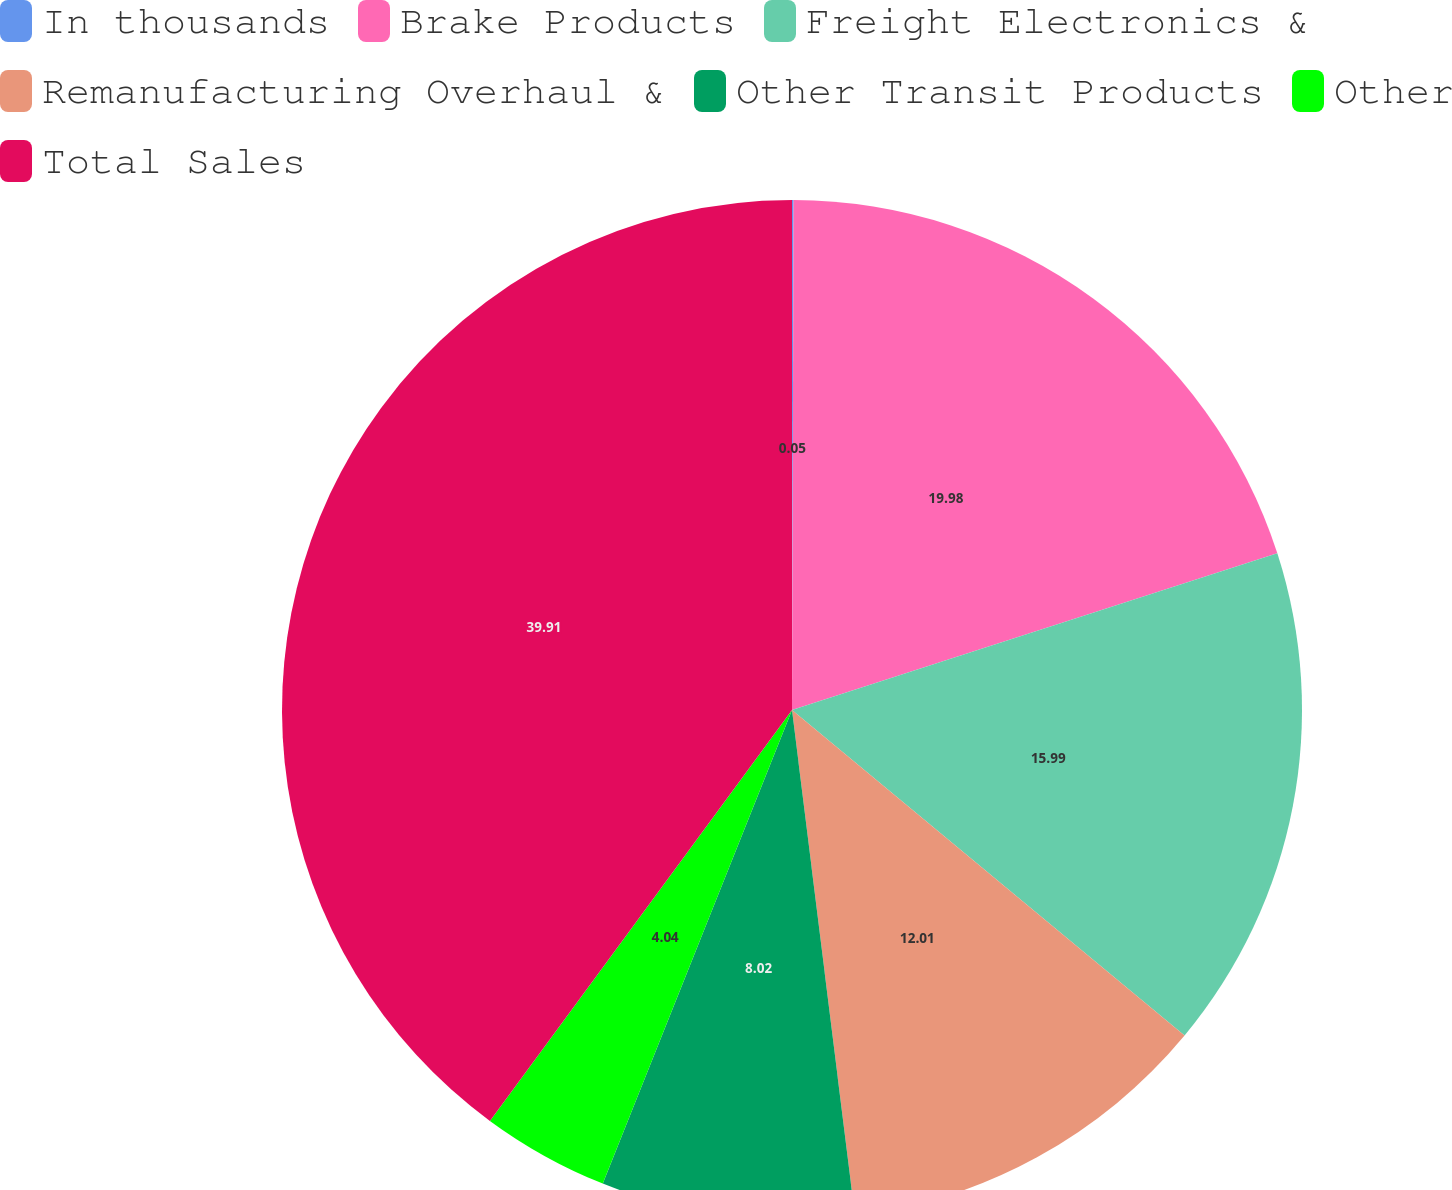<chart> <loc_0><loc_0><loc_500><loc_500><pie_chart><fcel>In thousands<fcel>Brake Products<fcel>Freight Electronics &<fcel>Remanufacturing Overhaul &<fcel>Other Transit Products<fcel>Other<fcel>Total Sales<nl><fcel>0.05%<fcel>19.98%<fcel>15.99%<fcel>12.01%<fcel>8.02%<fcel>4.04%<fcel>39.91%<nl></chart> 